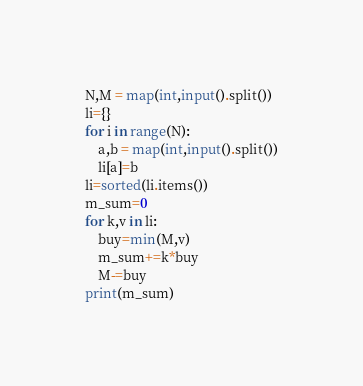<code> <loc_0><loc_0><loc_500><loc_500><_Python_>N,M = map(int,input().split())
li={}
for i in range(N):
	a,b = map(int,input().split())
	li[a]=b
li=sorted(li.items())
m_sum=0
for k,v in li:
	buy=min(M,v)
	m_sum+=k*buy
	M-=buy
print(m_sum)</code> 